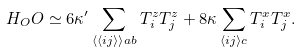Convert formula to latex. <formula><loc_0><loc_0><loc_500><loc_500>H _ { O } O \simeq 6 \kappa ^ { \prime } \sum _ { { \langle \langle i j \rangle \rangle } a b } T ^ { z } _ { i } T ^ { z } _ { j } + 8 \kappa \sum _ { \langle { i j } \rangle c } T ^ { x } _ { i } T ^ { x } _ { j } .</formula> 